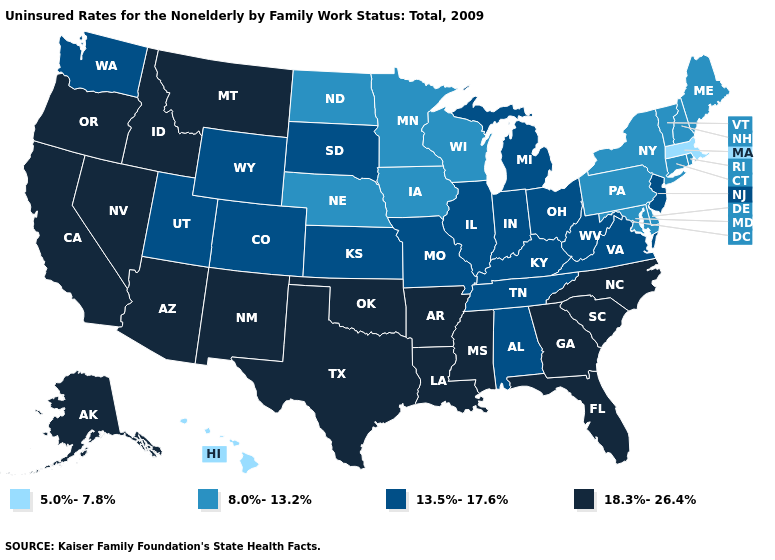What is the value of New Mexico?
Short answer required. 18.3%-26.4%. How many symbols are there in the legend?
Keep it brief. 4. Does Virginia have the same value as New Jersey?
Write a very short answer. Yes. What is the highest value in the USA?
Quick response, please. 18.3%-26.4%. Which states hav the highest value in the West?
Concise answer only. Alaska, Arizona, California, Idaho, Montana, Nevada, New Mexico, Oregon. What is the value of Arkansas?
Short answer required. 18.3%-26.4%. What is the value of Washington?
Write a very short answer. 13.5%-17.6%. Name the states that have a value in the range 5.0%-7.8%?
Be succinct. Hawaii, Massachusetts. What is the highest value in states that border New Jersey?
Be succinct. 8.0%-13.2%. Is the legend a continuous bar?
Short answer required. No. Does Nevada have the highest value in the USA?
Keep it brief. Yes. What is the lowest value in the USA?
Be succinct. 5.0%-7.8%. Name the states that have a value in the range 18.3%-26.4%?
Quick response, please. Alaska, Arizona, Arkansas, California, Florida, Georgia, Idaho, Louisiana, Mississippi, Montana, Nevada, New Mexico, North Carolina, Oklahoma, Oregon, South Carolina, Texas. Name the states that have a value in the range 18.3%-26.4%?
Quick response, please. Alaska, Arizona, Arkansas, California, Florida, Georgia, Idaho, Louisiana, Mississippi, Montana, Nevada, New Mexico, North Carolina, Oklahoma, Oregon, South Carolina, Texas. What is the value of Oregon?
Quick response, please. 18.3%-26.4%. 